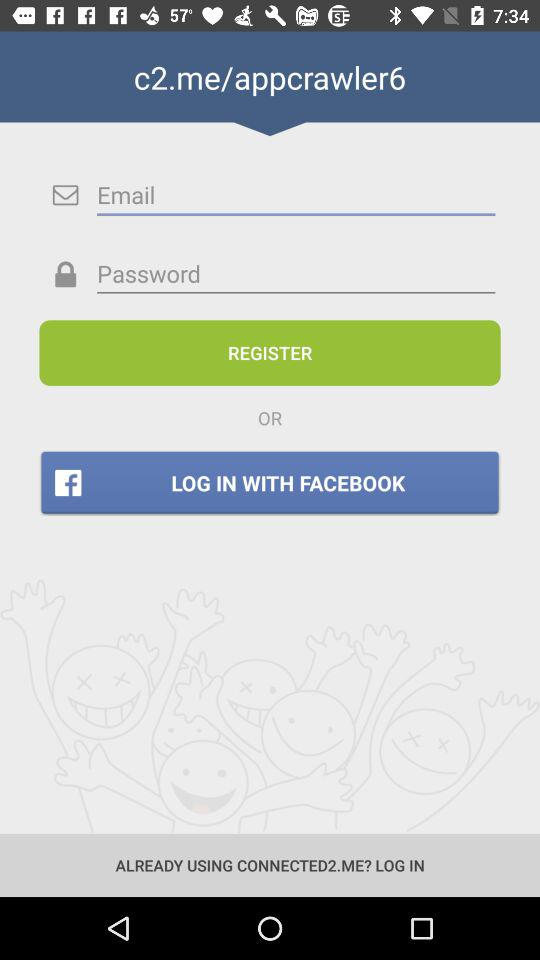Through what app can we log in? You can log in through "FACEBOOK". 